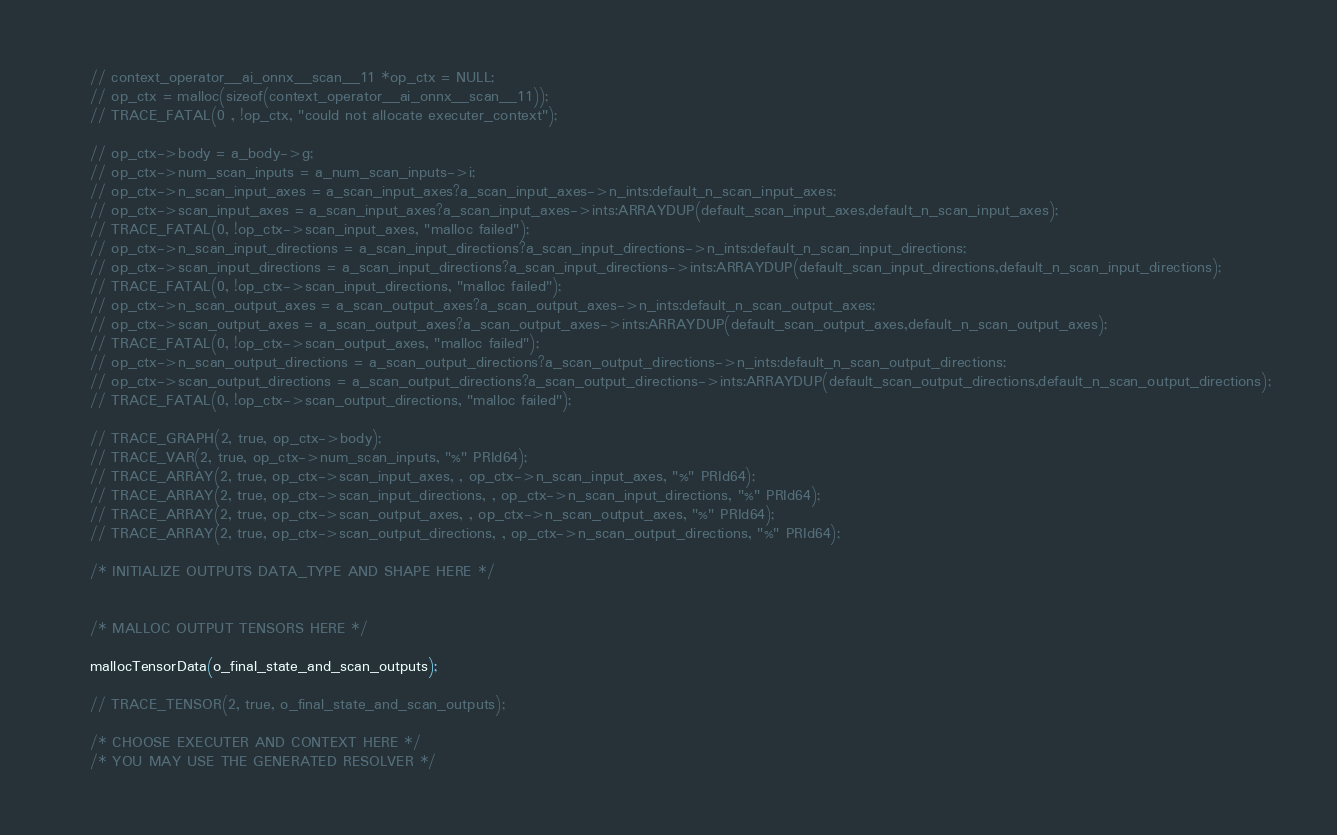<code> <loc_0><loc_0><loc_500><loc_500><_C_>
    // context_operator__ai_onnx__scan__11 *op_ctx = NULL;
    // op_ctx = malloc(sizeof(context_operator__ai_onnx__scan__11));
    // TRACE_FATAL(0 , !op_ctx, "could not allocate executer_context");

    // op_ctx->body = a_body->g;
    // op_ctx->num_scan_inputs = a_num_scan_inputs->i;
    // op_ctx->n_scan_input_axes = a_scan_input_axes?a_scan_input_axes->n_ints:default_n_scan_input_axes;
    // op_ctx->scan_input_axes = a_scan_input_axes?a_scan_input_axes->ints:ARRAYDUP(default_scan_input_axes,default_n_scan_input_axes);
    // TRACE_FATAL(0, !op_ctx->scan_input_axes, "malloc failed");
    // op_ctx->n_scan_input_directions = a_scan_input_directions?a_scan_input_directions->n_ints:default_n_scan_input_directions;
    // op_ctx->scan_input_directions = a_scan_input_directions?a_scan_input_directions->ints:ARRAYDUP(default_scan_input_directions,default_n_scan_input_directions);
    // TRACE_FATAL(0, !op_ctx->scan_input_directions, "malloc failed");
    // op_ctx->n_scan_output_axes = a_scan_output_axes?a_scan_output_axes->n_ints:default_n_scan_output_axes;
    // op_ctx->scan_output_axes = a_scan_output_axes?a_scan_output_axes->ints:ARRAYDUP(default_scan_output_axes,default_n_scan_output_axes);
    // TRACE_FATAL(0, !op_ctx->scan_output_axes, "malloc failed");
    // op_ctx->n_scan_output_directions = a_scan_output_directions?a_scan_output_directions->n_ints:default_n_scan_output_directions;
    // op_ctx->scan_output_directions = a_scan_output_directions?a_scan_output_directions->ints:ARRAYDUP(default_scan_output_directions,default_n_scan_output_directions);
    // TRACE_FATAL(0, !op_ctx->scan_output_directions, "malloc failed");

    // TRACE_GRAPH(2, true, op_ctx->body);
    // TRACE_VAR(2, true, op_ctx->num_scan_inputs, "%" PRId64);
    // TRACE_ARRAY(2, true, op_ctx->scan_input_axes, , op_ctx->n_scan_input_axes, "%" PRId64);
    // TRACE_ARRAY(2, true, op_ctx->scan_input_directions, , op_ctx->n_scan_input_directions, "%" PRId64);
    // TRACE_ARRAY(2, true, op_ctx->scan_output_axes, , op_ctx->n_scan_output_axes, "%" PRId64);
    // TRACE_ARRAY(2, true, op_ctx->scan_output_directions, , op_ctx->n_scan_output_directions, "%" PRId64);

    /* INITIALIZE OUTPUTS DATA_TYPE AND SHAPE HERE */


    /* MALLOC OUTPUT TENSORS HERE */

    mallocTensorData(o_final_state_and_scan_outputs);

    // TRACE_TENSOR(2, true, o_final_state_and_scan_outputs);

    /* CHOOSE EXECUTER AND CONTEXT HERE */
    /* YOU MAY USE THE GENERATED RESOLVER */
</code> 